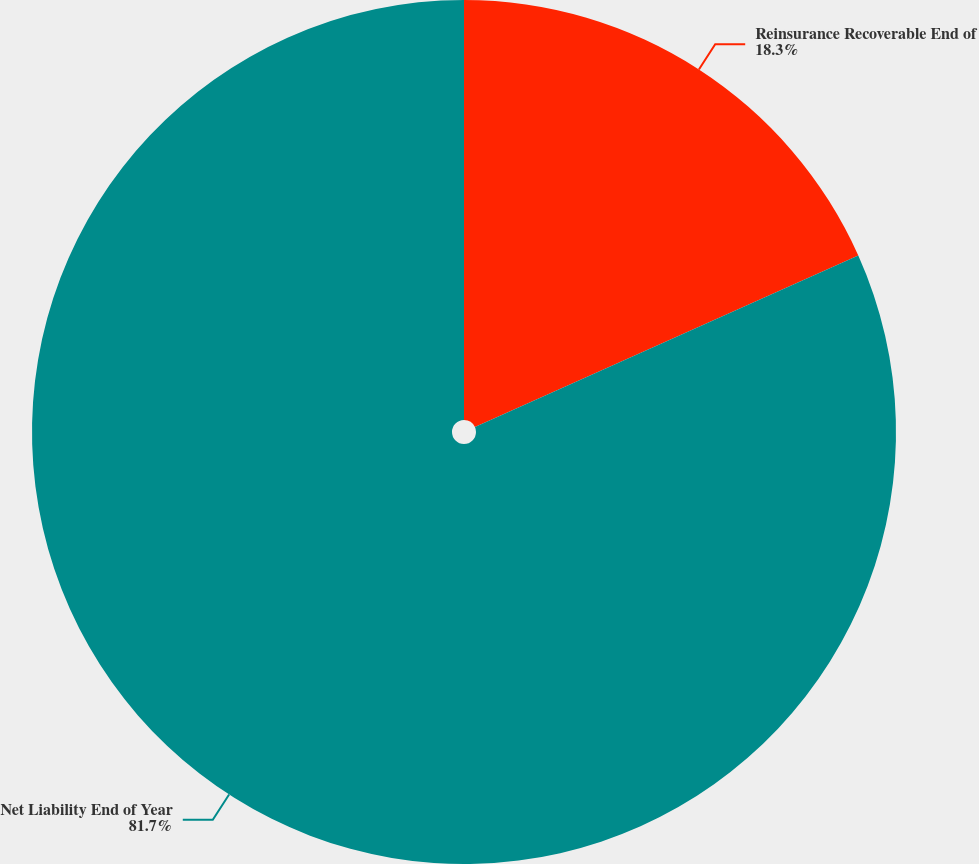Convert chart to OTSL. <chart><loc_0><loc_0><loc_500><loc_500><pie_chart><fcel>Reinsurance Recoverable End of<fcel>Net Liability End of Year<nl><fcel>18.3%<fcel>81.7%<nl></chart> 